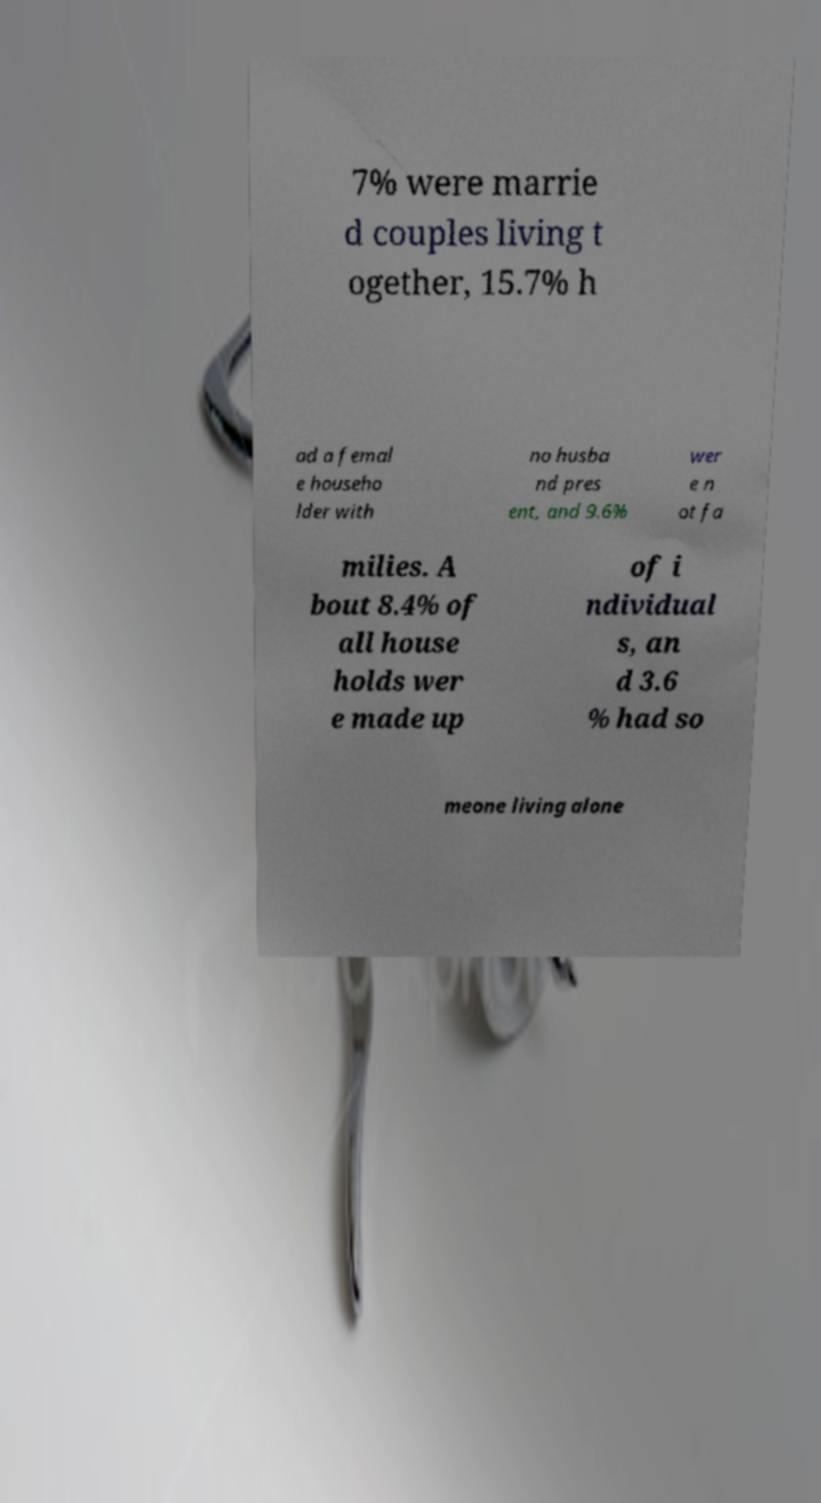Could you extract and type out the text from this image? 7% were marrie d couples living t ogether, 15.7% h ad a femal e househo lder with no husba nd pres ent, and 9.6% wer e n ot fa milies. A bout 8.4% of all house holds wer e made up of i ndividual s, an d 3.6 % had so meone living alone 